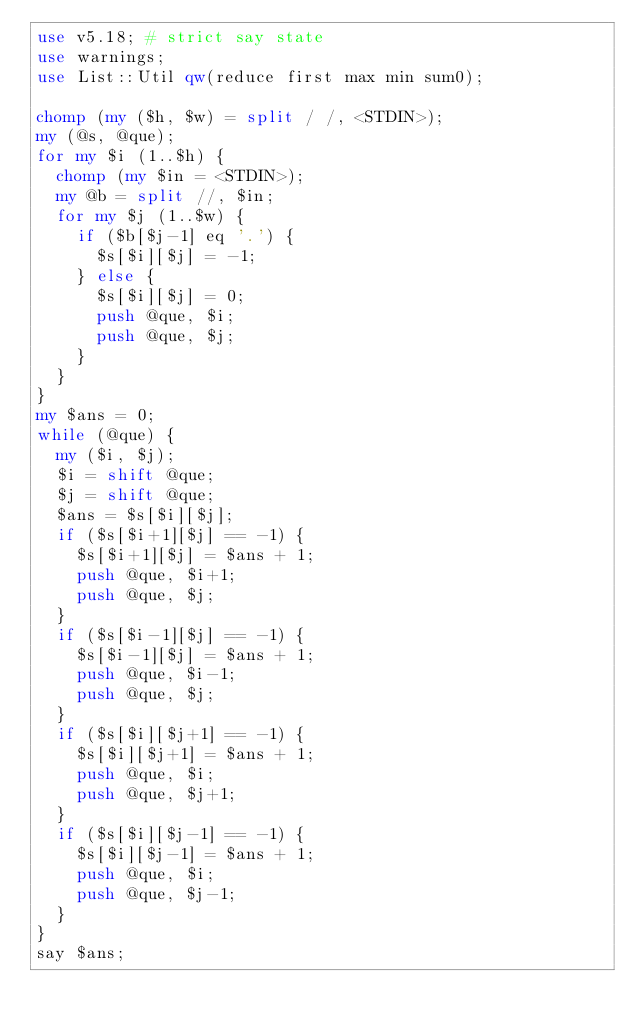Convert code to text. <code><loc_0><loc_0><loc_500><loc_500><_Perl_>use v5.18; # strict say state
use warnings;
use List::Util qw(reduce first max min sum0);

chomp (my ($h, $w) = split / /, <STDIN>);
my (@s, @que);
for my $i (1..$h) {
  chomp (my $in = <STDIN>);
  my @b = split //, $in;
  for my $j (1..$w) {
    if ($b[$j-1] eq '.') {
      $s[$i][$j] = -1;
    } else {
      $s[$i][$j] = 0;
      push @que, $i;
      push @que, $j;
    }
  }
}
my $ans = 0;
while (@que) {
  my ($i, $j);
  $i = shift @que;
  $j = shift @que;
  $ans = $s[$i][$j];
  if ($s[$i+1][$j] == -1) {
    $s[$i+1][$j] = $ans + 1;
    push @que, $i+1;
    push @que, $j;
  }
  if ($s[$i-1][$j] == -1) {
    $s[$i-1][$j] = $ans + 1;
    push @que, $i-1;
    push @que, $j;
  }
  if ($s[$i][$j+1] == -1) {
    $s[$i][$j+1] = $ans + 1;
    push @que, $i;
    push @que, $j+1;
  }
  if ($s[$i][$j-1] == -1) {
    $s[$i][$j-1] = $ans + 1;
    push @que, $i;
    push @que, $j-1;
  }
}
say $ans;</code> 